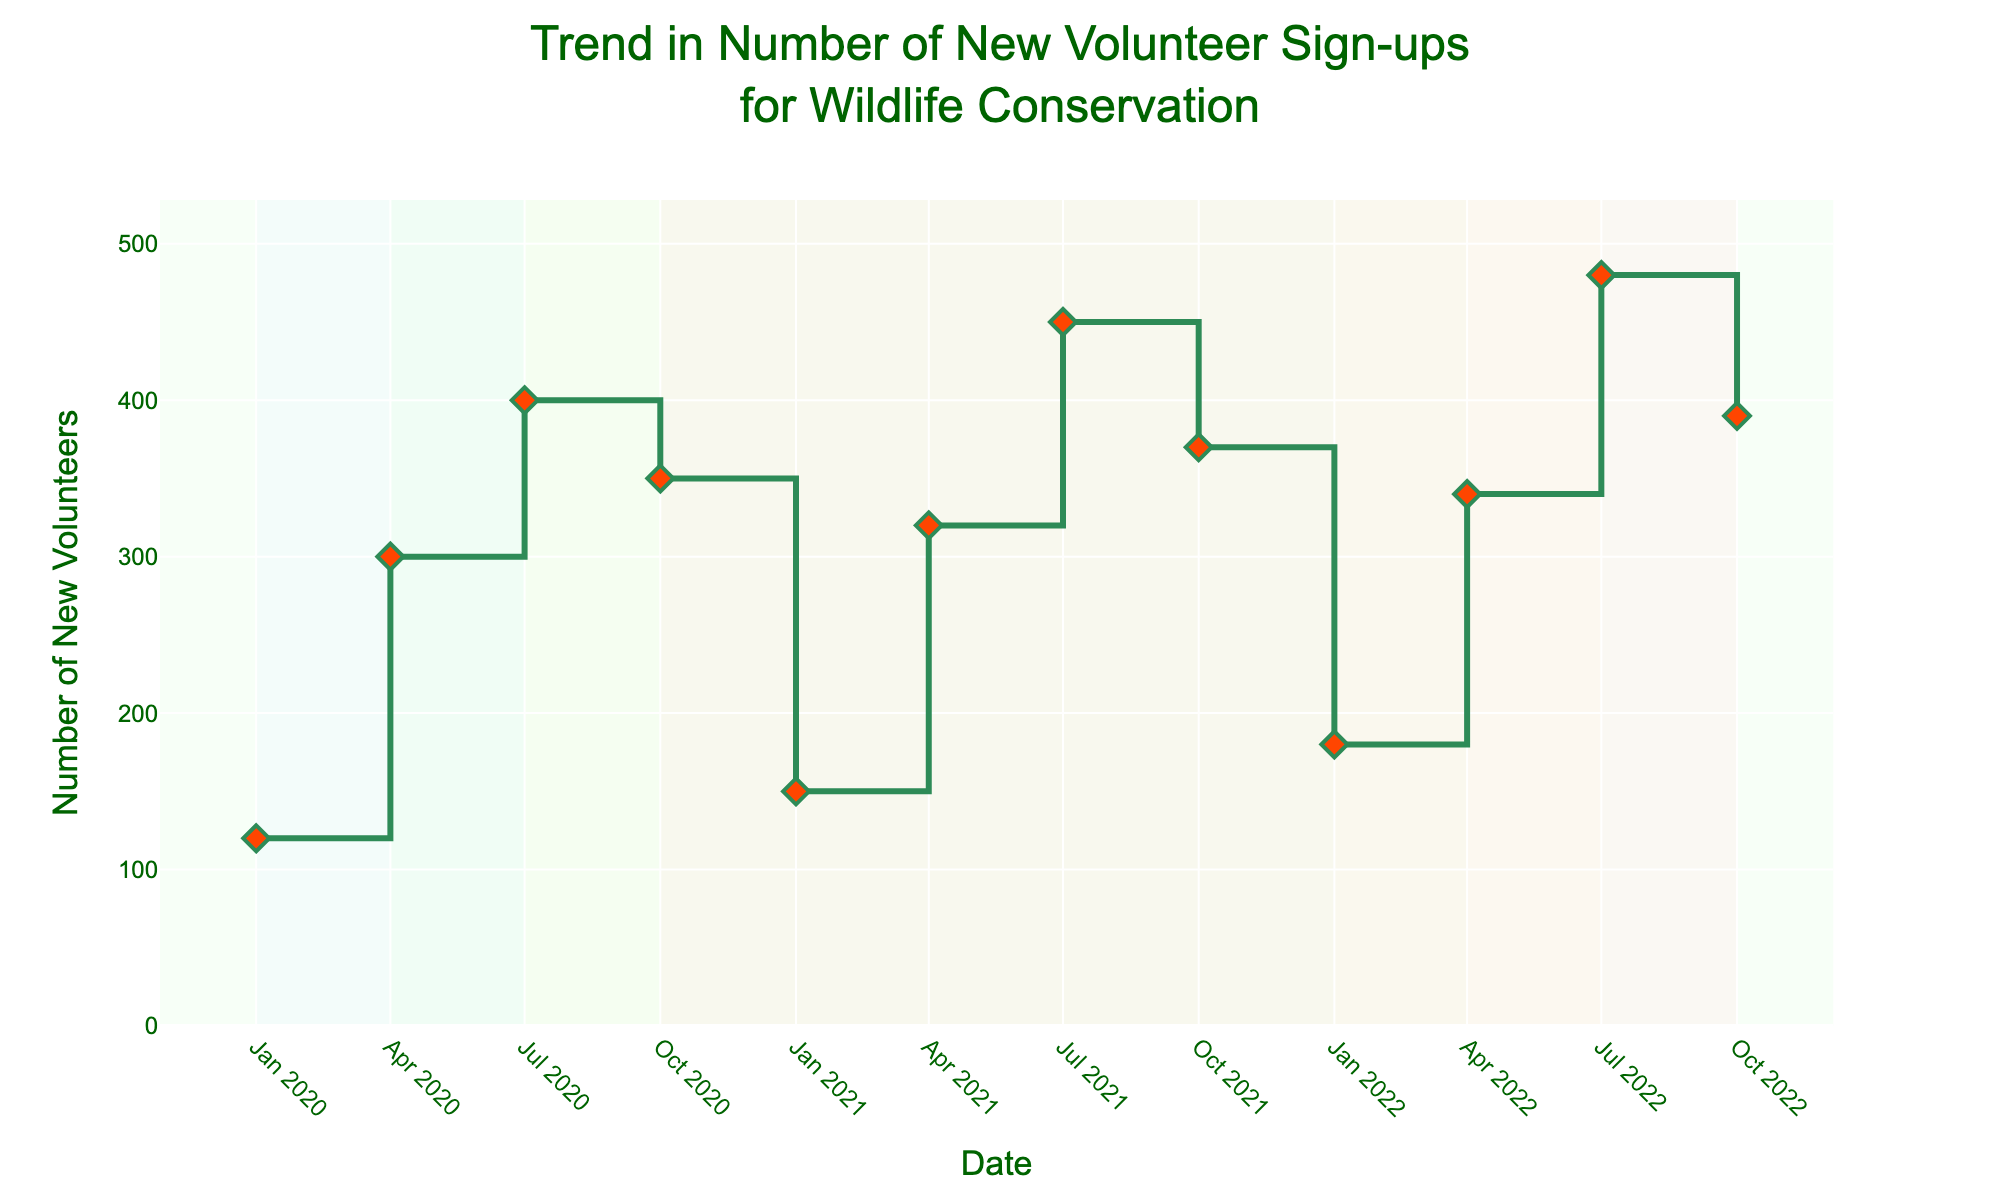What is the title of the figure? The title of the plot is generally located at the top and provides an overview of what the figure is about.
Answer: Trend in Number of New Volunteer Sign-ups for Wildlife Conservation During which season did the highest number of new volunteer sign-ups occur in 2022? Look for the peak point in 2022 and identify the corresponding season.
Answer: Summer How much did the number of new volunteers increase from Winter 2021 to Fall 2021? Subtract the number of new volunteers in Winter 2021 from the number in Fall 2021: 370 - 150 = 220.
Answer: 220 In which season did the number of new volunteers show the most consistent increase year over year? Compare the height of the increases for each season from 2020 to 2022.
Answer: Summer Which year showed the highest increase in volunteer sign-ups between Winter and Spring? Examine the jump between Winter and Spring for the three years by looking at the vertical segments of the steps. The largest jump is between Winter and Spring 2020: 300 - 120 = 180.
Answer: 2020 Is there any season that consistently has more new volunteer sign-ups than Winter across all three years? Compare the number of volunteer sign-ups in Winter to other seasons for 2020, 2021, and 2022.
Answer: Spring, Summer, Fall Calculate the average number of new volunteers for Summer over the three years. Add the number of new volunteers for Summer in 2020, 2021, and 2022 and divide by 3: (400 + 450 + 480) / 3 = 1,330 / 3.
Answer: 443.33 Between which consecutive years did the Fall season have the smallest increase in new volunteer sign-ups? Examine the height of the increase between Fall of consecutive years: 350 to 370 in 2021 and 370 to 390 in 2022. The smallest increase is between 2020 and 2021: 370 - 350 = 20.
Answer: 2020 to 2021 